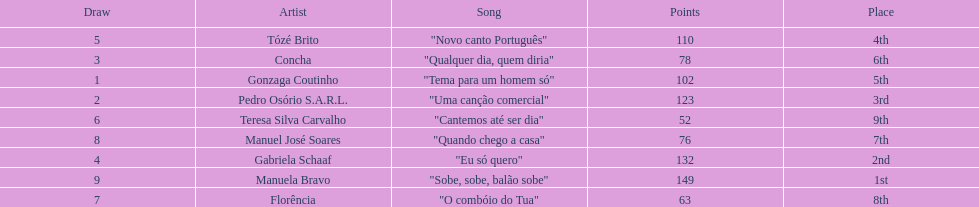Who sang "eu só quero" as their song in the eurovision song contest of 1979? Gabriela Schaaf. 